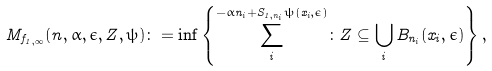<formula> <loc_0><loc_0><loc_500><loc_500>M _ { f _ { 1 , \infty } } ( n , \alpha , \epsilon , Z , \psi ) \colon = \inf \left \{ \sum _ { i } ^ { - \alpha n _ { i } + S _ { 1 , n _ { i } } \psi ( x _ { i } , \epsilon ) } \colon Z \subseteq \bigcup _ { i } B _ { n _ { i } } ( x _ { i } , \epsilon ) \right \} ,</formula> 